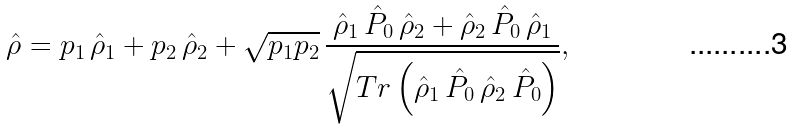Convert formula to latex. <formula><loc_0><loc_0><loc_500><loc_500>\hat { \rho } = p _ { 1 } \, \hat { \rho } _ { 1 } + p _ { 2 } \, \hat { \rho } _ { 2 } + \sqrt { p _ { 1 } p _ { 2 } } \, \frac { \hat { \rho } _ { 1 } \, \hat { P } _ { 0 } \, \hat { \rho } _ { 2 } + \hat { \rho } _ { 2 } \, \hat { P } _ { 0 } \, \hat { \rho } _ { 1 } } { \sqrt { T r \left ( \hat { \rho } _ { 1 } \, \hat { P } _ { 0 } \, \hat { \rho } _ { 2 } \, \hat { P } _ { 0 } \right ) } } ,</formula> 